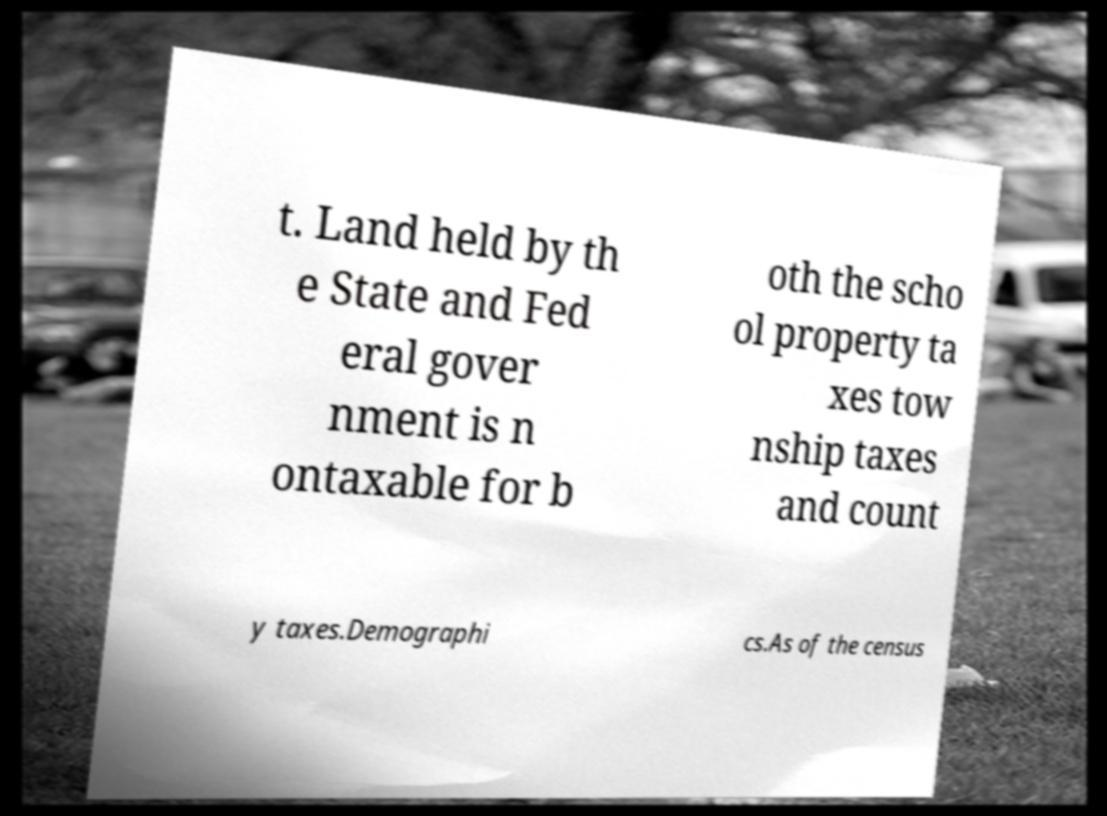Please identify and transcribe the text found in this image. t. Land held by th e State and Fed eral gover nment is n ontaxable for b oth the scho ol property ta xes tow nship taxes and count y taxes.Demographi cs.As of the census 